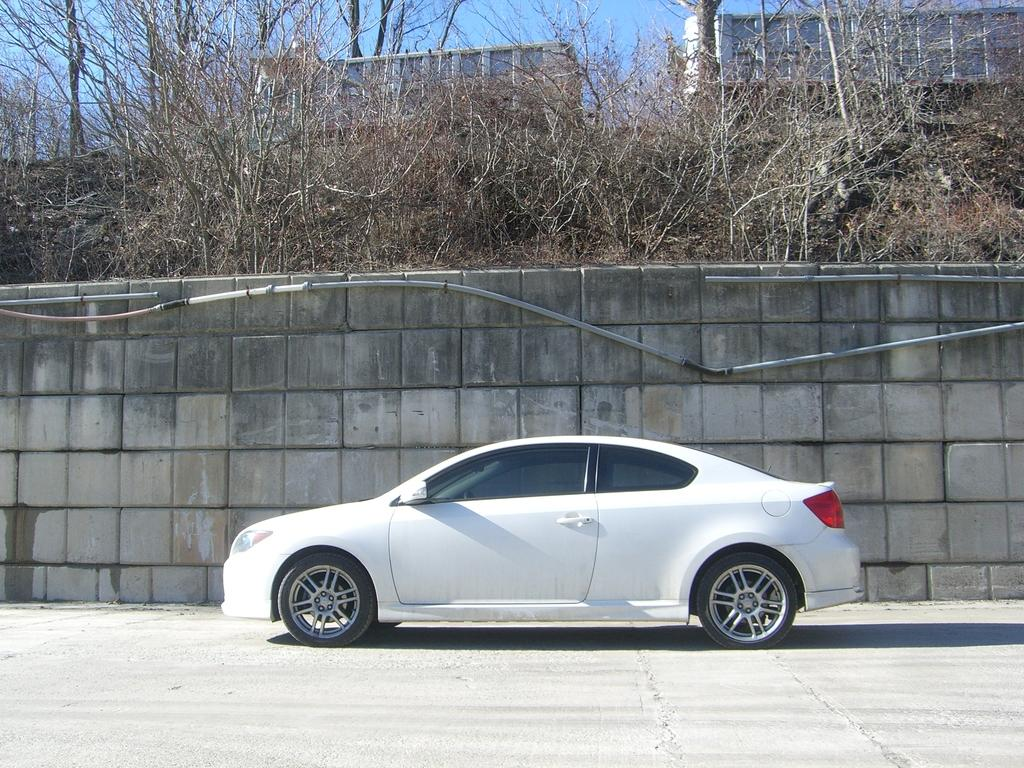What is the main subject of the image? The main subject of the image is a car. Where is the car located in the image? The car is on the road in the image. What can be seen in the background of the image? In the background of the image, there is a wall, plants, trees, buildings, and the sky. What type of boundary can be seen in the image? There is no boundary present in the image. What time of day is depicted in the image? The time of day cannot be determined from the image, as there is no indication of the sun's position or any artificial lighting. 